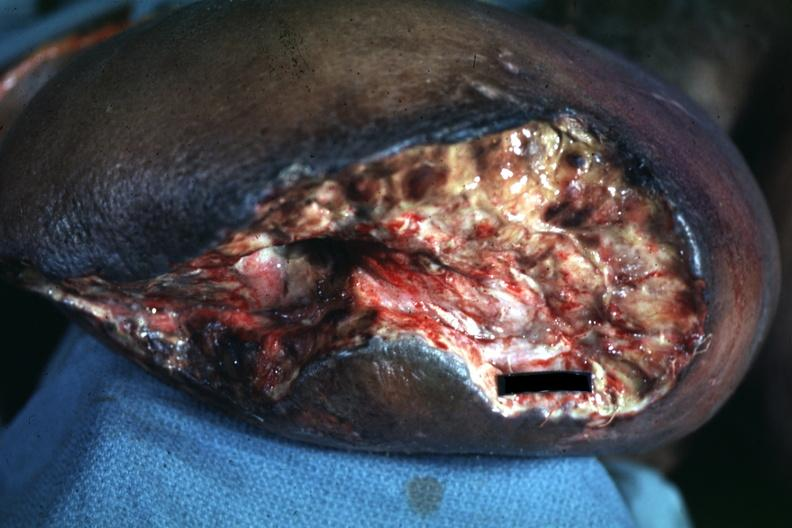how does wound appear to be thigh?
Answer the question using a single word or phrase. Mid 